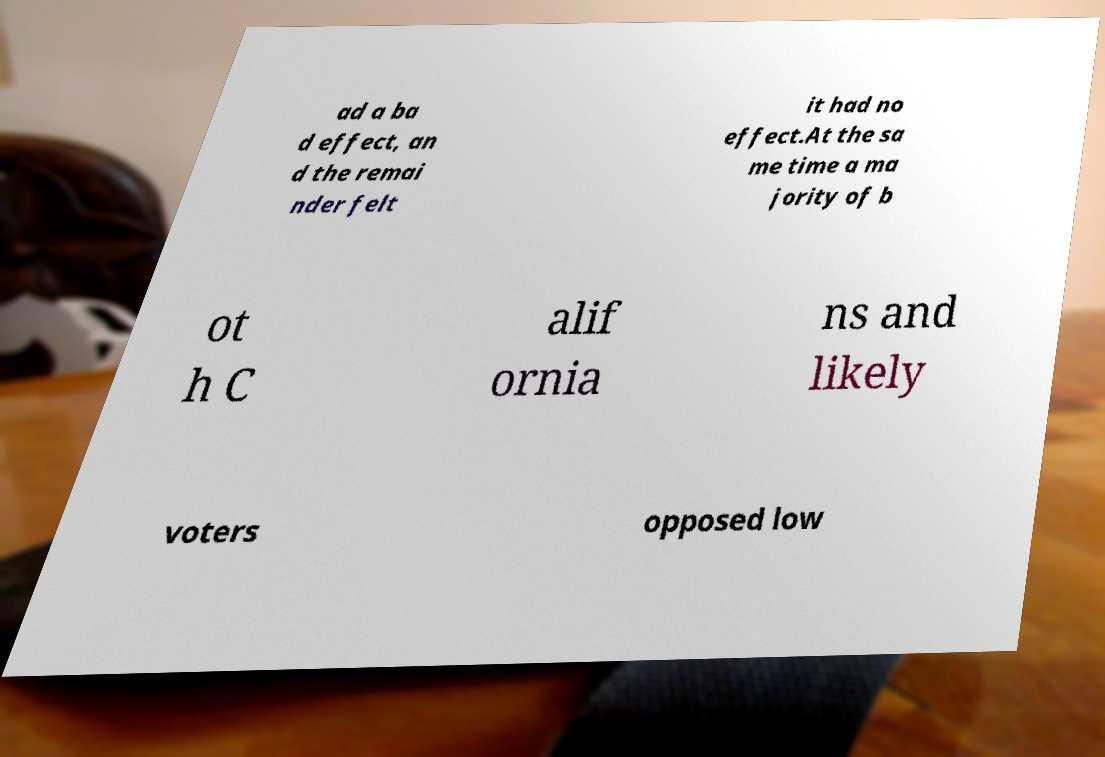What messages or text are displayed in this image? I need them in a readable, typed format. ad a ba d effect, an d the remai nder felt it had no effect.At the sa me time a ma jority of b ot h C alif ornia ns and likely voters opposed low 